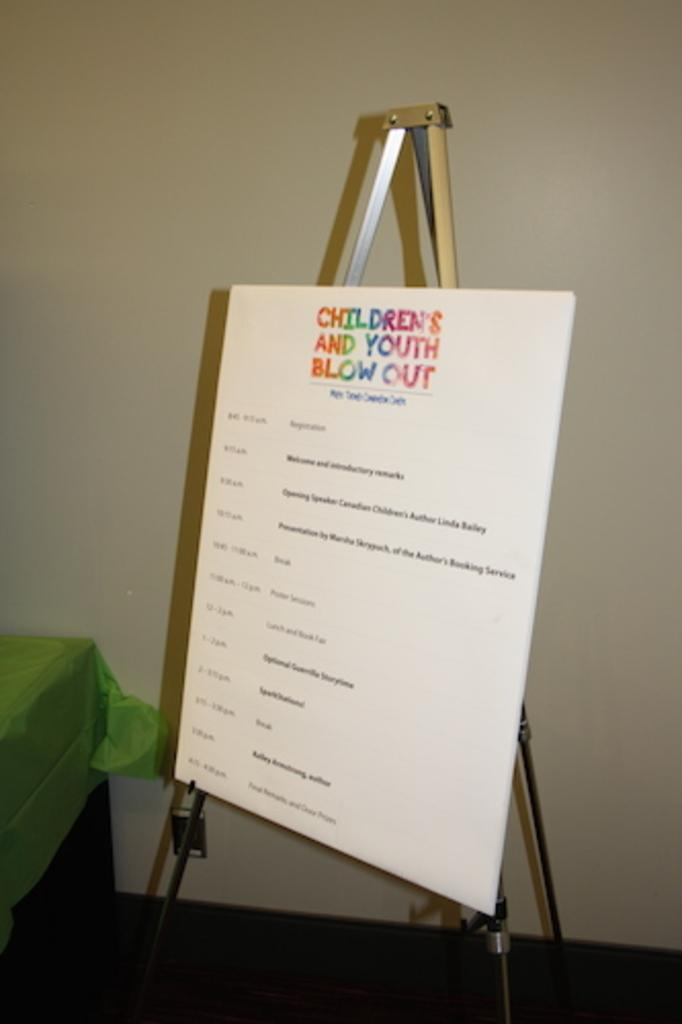Provide a one-sentence caption for the provided image. an easel  holding board for children's and youth blow out that lists times and events. 